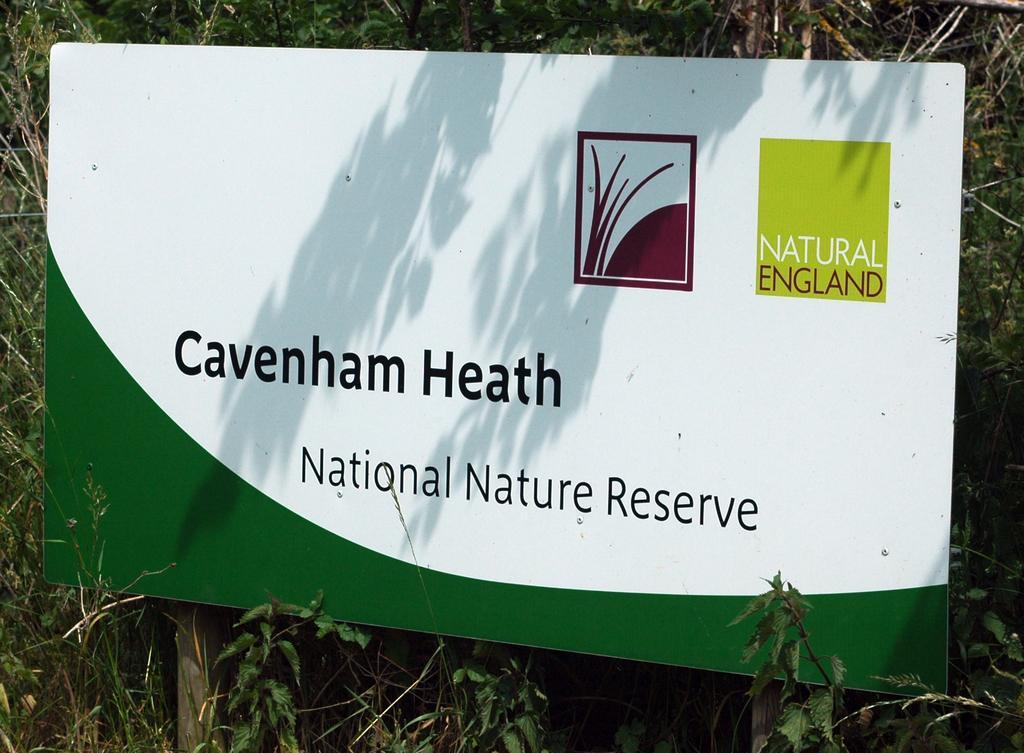Can you describe this image briefly? In this picture we can see a nature reserve board surrounded by trees and bushes. 